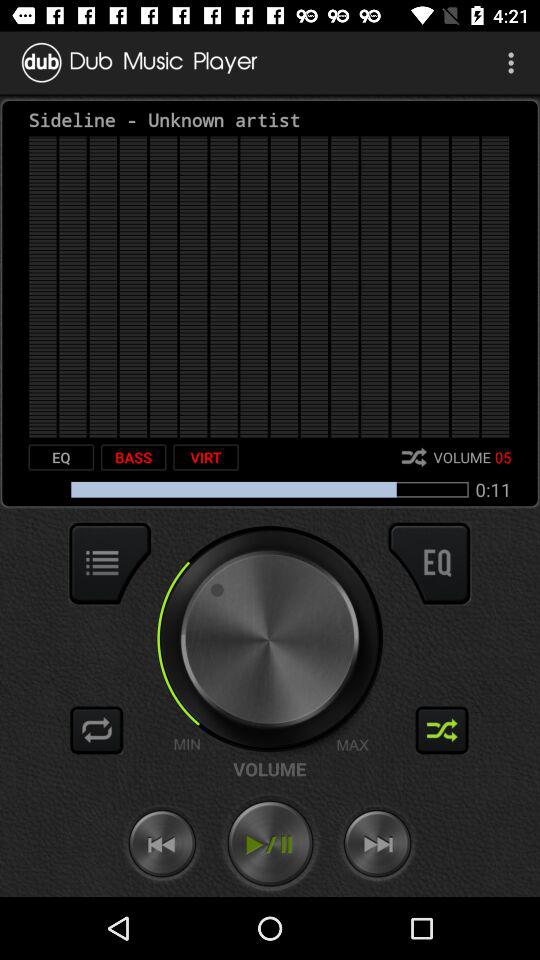What is the level of volume? The level of volume is 5. 